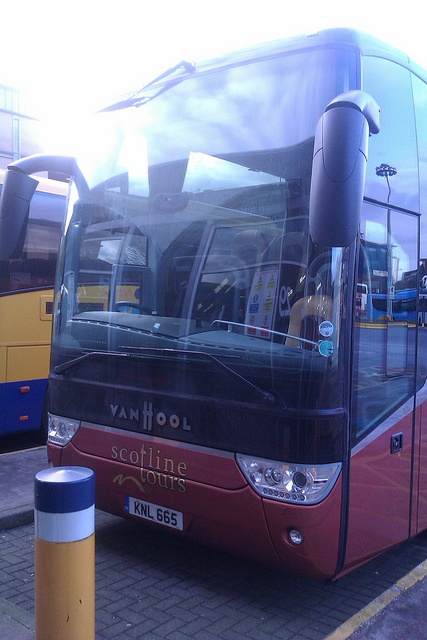Describe the objects in this image and their specific colors. I can see bus in white, black, gray, and navy tones and bus in white, navy, gray, and tan tones in this image. 